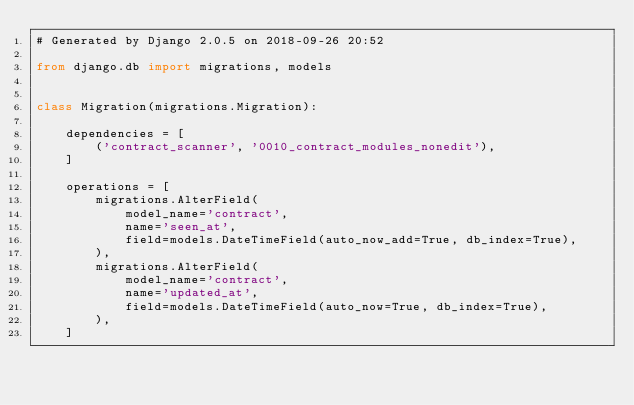Convert code to text. <code><loc_0><loc_0><loc_500><loc_500><_Python_># Generated by Django 2.0.5 on 2018-09-26 20:52

from django.db import migrations, models


class Migration(migrations.Migration):

    dependencies = [
        ('contract_scanner', '0010_contract_modules_nonedit'),
    ]

    operations = [
        migrations.AlterField(
            model_name='contract',
            name='seen_at',
            field=models.DateTimeField(auto_now_add=True, db_index=True),
        ),
        migrations.AlterField(
            model_name='contract',
            name='updated_at',
            field=models.DateTimeField(auto_now=True, db_index=True),
        ),
    ]
</code> 